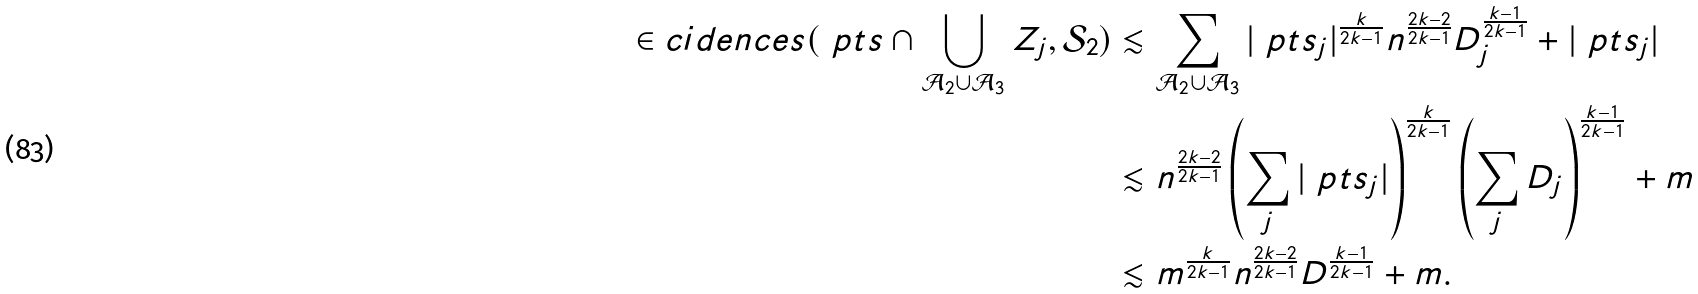<formula> <loc_0><loc_0><loc_500><loc_500>\in c i d e n c e s ( \ p t s \cap \bigcup _ { \mathcal { A } _ { 2 } \cup \mathcal { A } _ { 3 } } Z _ { j } , \mathcal { S } _ { 2 } ) & \lesssim \sum _ { \mathcal { A } _ { 2 } \cup \mathcal { A } _ { 3 } } | \ p t s _ { j } | ^ { \frac { k } { 2 k - 1 } } n ^ { \frac { 2 k - 2 } { 2 k - 1 } } D _ { j } ^ { \frac { k - 1 } { 2 k - 1 } } + | \ p t s _ { j } | \\ & \lesssim n ^ { \frac { 2 k - 2 } { 2 k - 1 } } \left ( \sum _ { j } | \ p t s _ { j } | \right ) ^ { \frac { k } { 2 k - 1 } } \left ( \sum _ { j } D _ { j } \right ) ^ { \frac { k - 1 } { 2 k - 1 } } + m \\ & \lesssim m ^ { \frac { k } { 2 k - 1 } } n ^ { \frac { 2 k - 2 } { 2 k - 1 } } D ^ { \frac { k - 1 } { 2 k - 1 } } + m .</formula> 